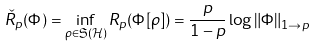Convert formula to latex. <formula><loc_0><loc_0><loc_500><loc_500>\check { R } _ { p } ( \Phi ) = \inf _ { \rho \in \mathfrak { S } ( \mathcal { H } ) } R _ { p } ( \Phi [ \rho ] ) = \frac { p } { 1 - p } \log \left \| \Phi \right \| _ { 1 \rightarrow p }</formula> 